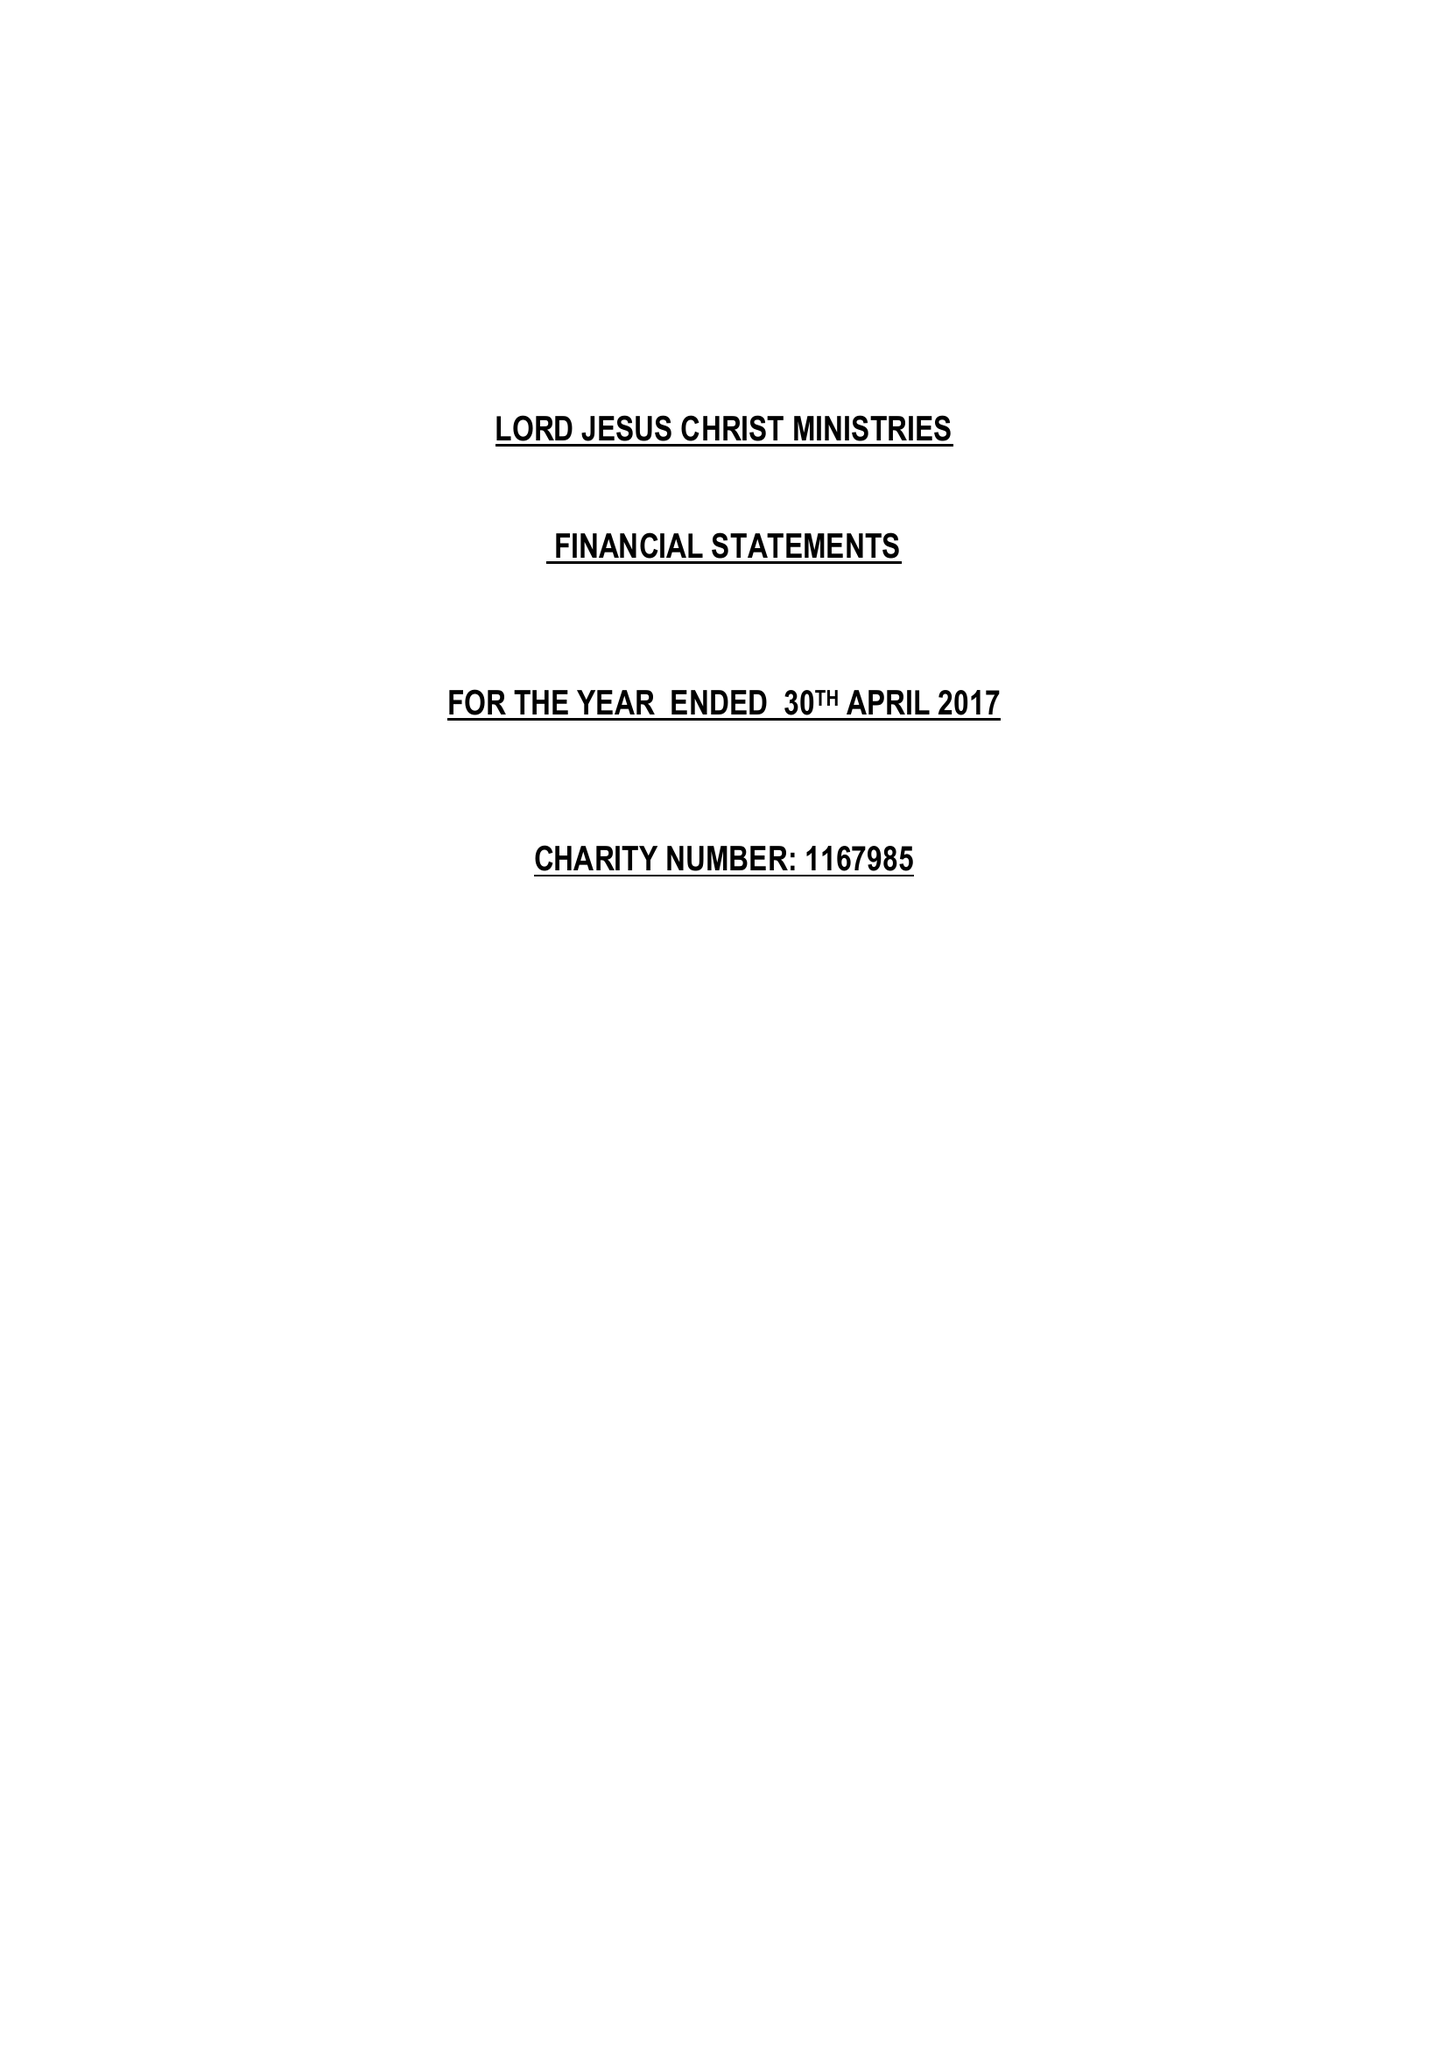What is the value for the address__post_town?
Answer the question using a single word or phrase. MILTON KEYNES 